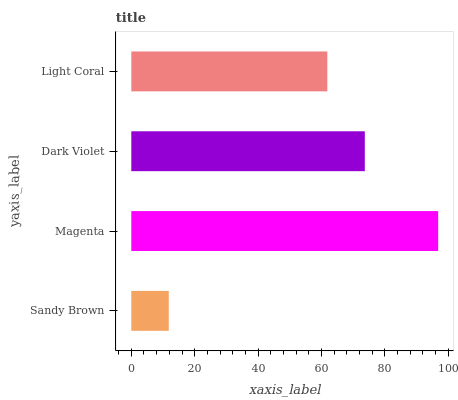Is Sandy Brown the minimum?
Answer yes or no. Yes. Is Magenta the maximum?
Answer yes or no. Yes. Is Dark Violet the minimum?
Answer yes or no. No. Is Dark Violet the maximum?
Answer yes or no. No. Is Magenta greater than Dark Violet?
Answer yes or no. Yes. Is Dark Violet less than Magenta?
Answer yes or no. Yes. Is Dark Violet greater than Magenta?
Answer yes or no. No. Is Magenta less than Dark Violet?
Answer yes or no. No. Is Dark Violet the high median?
Answer yes or no. Yes. Is Light Coral the low median?
Answer yes or no. Yes. Is Sandy Brown the high median?
Answer yes or no. No. Is Sandy Brown the low median?
Answer yes or no. No. 